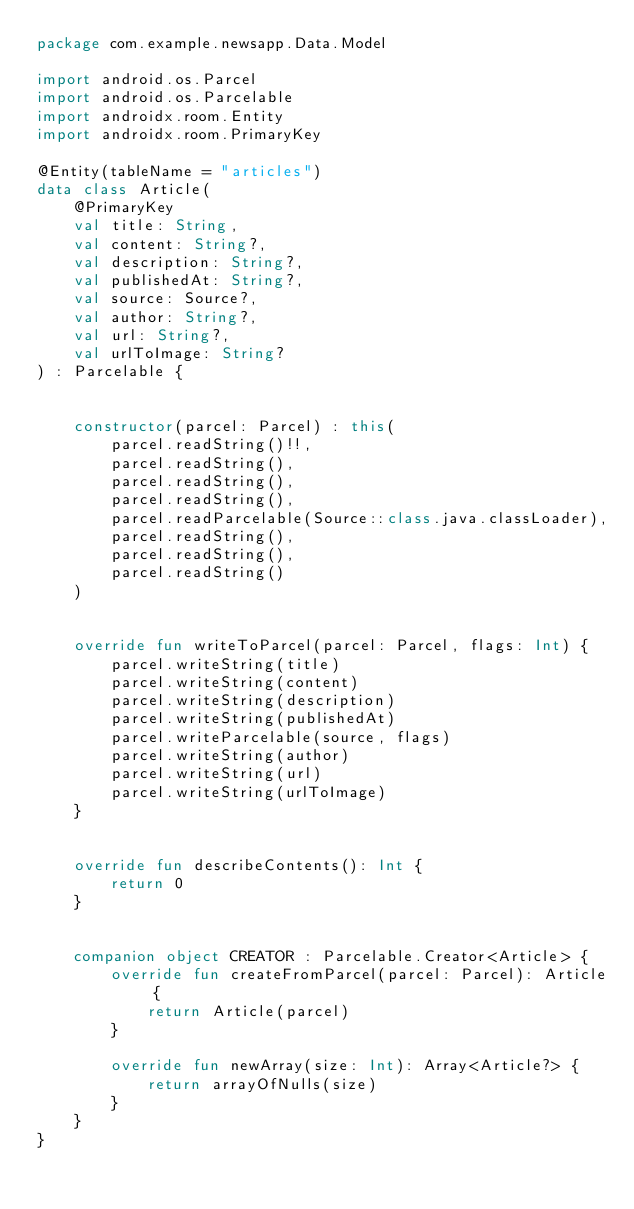<code> <loc_0><loc_0><loc_500><loc_500><_Kotlin_>package com.example.newsapp.Data.Model

import android.os.Parcel
import android.os.Parcelable
import androidx.room.Entity
import androidx.room.PrimaryKey

@Entity(tableName = "articles")
data class Article(
    @PrimaryKey
    val title: String,
    val content: String?,
    val description: String?,
    val publishedAt: String?,
    val source: Source?,
    val author: String?,
    val url: String?,
    val urlToImage: String?
) : Parcelable {


    constructor(parcel: Parcel) : this(
        parcel.readString()!!,
        parcel.readString(),
        parcel.readString(),
        parcel.readString(),
        parcel.readParcelable(Source::class.java.classLoader),
        parcel.readString(),
        parcel.readString(),
        parcel.readString()
    )


    override fun writeToParcel(parcel: Parcel, flags: Int) {
        parcel.writeString(title)
        parcel.writeString(content)
        parcel.writeString(description)
        parcel.writeString(publishedAt)
        parcel.writeParcelable(source, flags)
        parcel.writeString(author)
        parcel.writeString(url)
        parcel.writeString(urlToImage)
    }


    override fun describeContents(): Int {
        return 0
    }


    companion object CREATOR : Parcelable.Creator<Article> {
        override fun createFromParcel(parcel: Parcel): Article {
            return Article(parcel)
        }

        override fun newArray(size: Int): Array<Article?> {
            return arrayOfNulls(size)
        }
    }
}

</code> 